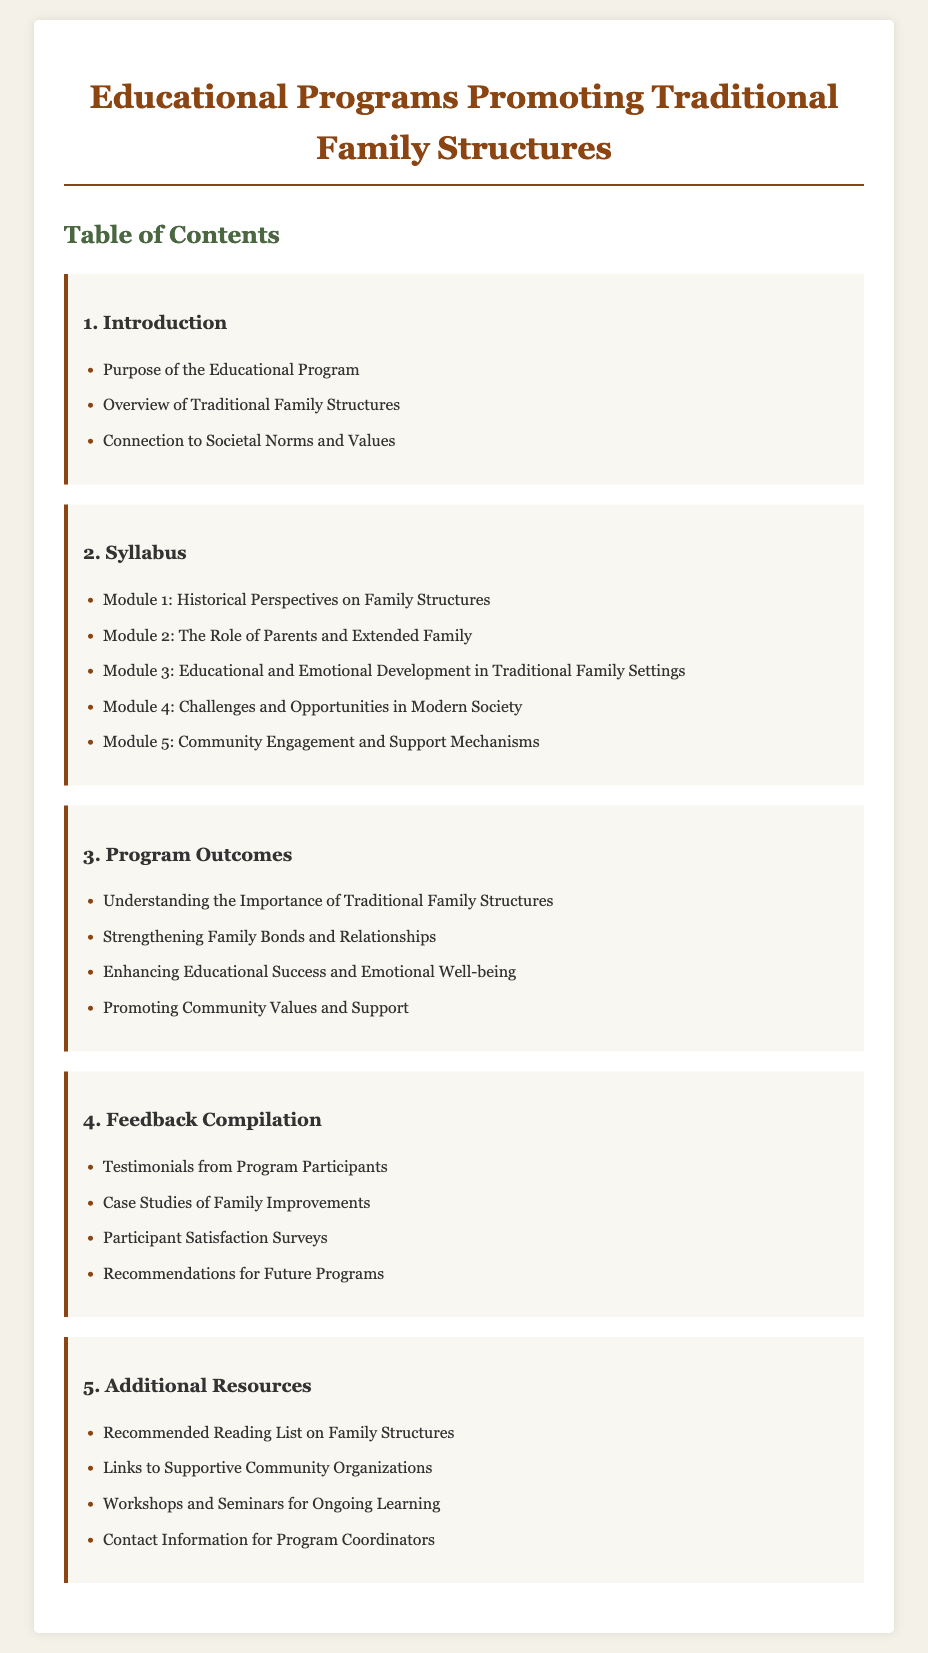What is the purpose of the educational program? The purpose of the educational program is outlined in the introduction section of the document.
Answer: Purpose of the Educational Program How many modules are included in the syllabus? The syllabus section lists the number of modules included in the educational program.
Answer: 5 What is the first module in the syllabus? The syllabus section provides the titles of all modules, with the first being listed first.
Answer: Module 1: Historical Perspectives on Family Structures What is one outcome of the program? The program outcomes section highlights multiple outcomes, one of which can be found there.
Answer: Understanding the Importance of Traditional Family Structures What type of feedback is compiled in the feedback section? The feedback compilation section describes various types of feedback collected from participants.
Answer: Testimonials from Program Participants Which community value is promoted through the program outcomes? The program outcomes section explicitly mentions values related to the community.
Answer: Promoting Community Values and Support What is the title of the document? The title is presented at the top of the document and establishes the main focus.
Answer: Educational Programs Promoting Traditional Family Structures Where can participants find ongoing learning opportunities? The additional resources section provides a list of where participants can find continued learning options.
Answer: Workshops and Seminars for Ongoing Learning 